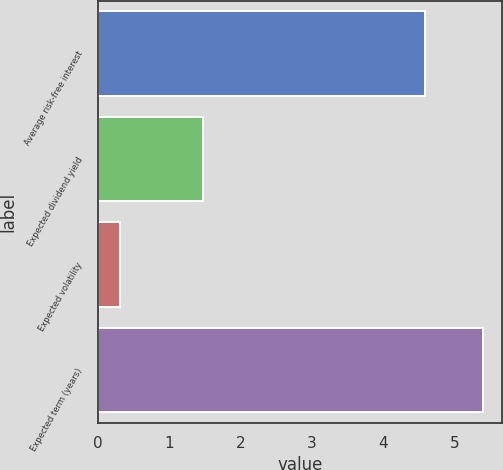<chart> <loc_0><loc_0><loc_500><loc_500><bar_chart><fcel>Average risk-free interest<fcel>Expected dividend yield<fcel>Expected volatility<fcel>Expected term (years)<nl><fcel>4.59<fcel>1.47<fcel>0.31<fcel>5.4<nl></chart> 